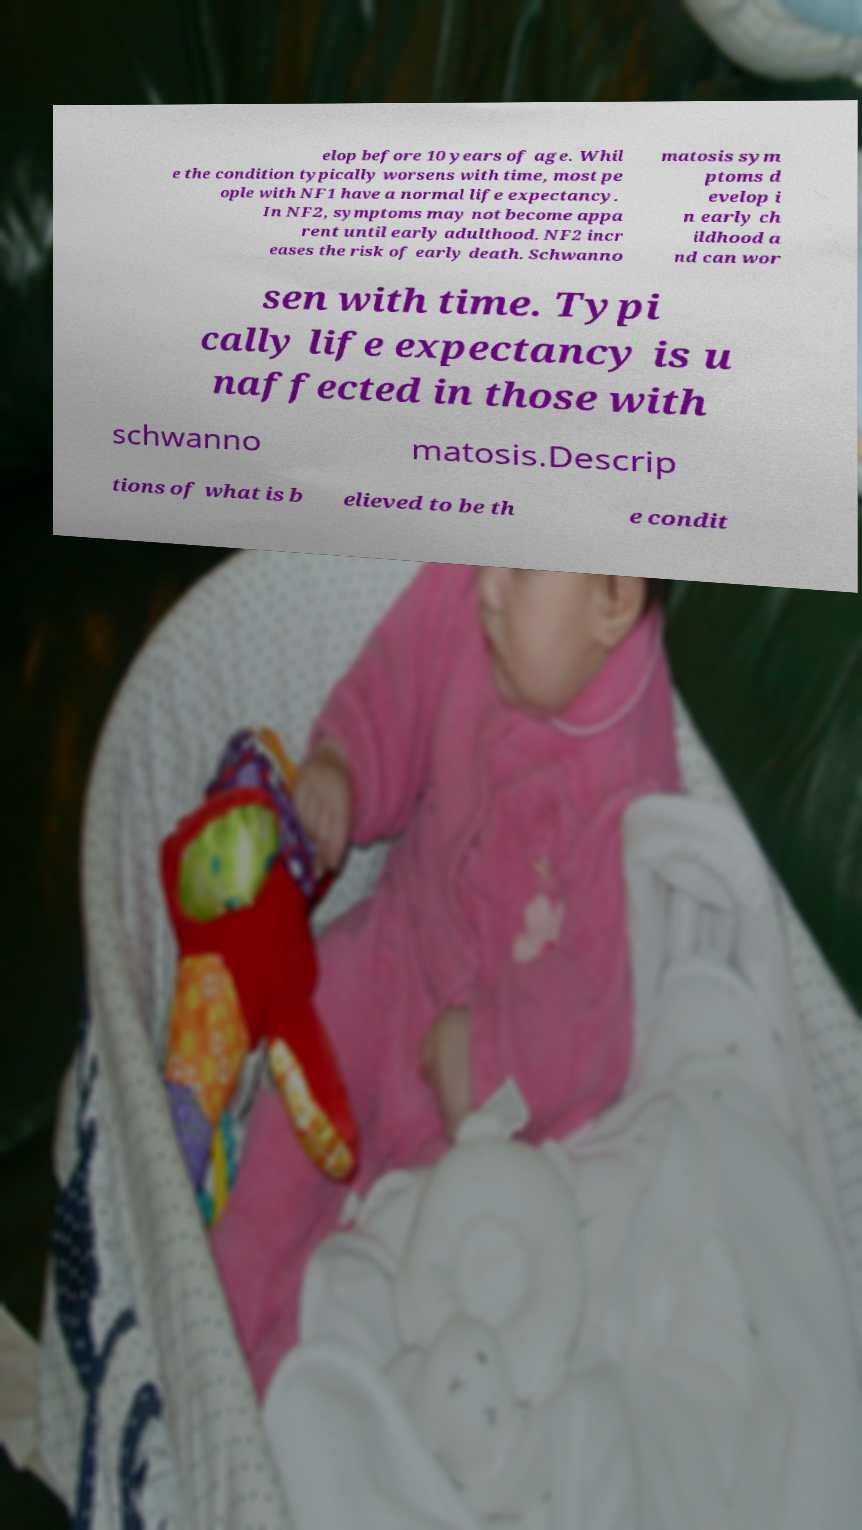There's text embedded in this image that I need extracted. Can you transcribe it verbatim? elop before 10 years of age. Whil e the condition typically worsens with time, most pe ople with NF1 have a normal life expectancy. In NF2, symptoms may not become appa rent until early adulthood. NF2 incr eases the risk of early death. Schwanno matosis sym ptoms d evelop i n early ch ildhood a nd can wor sen with time. Typi cally life expectancy is u naffected in those with schwanno matosis.Descrip tions of what is b elieved to be th e condit 